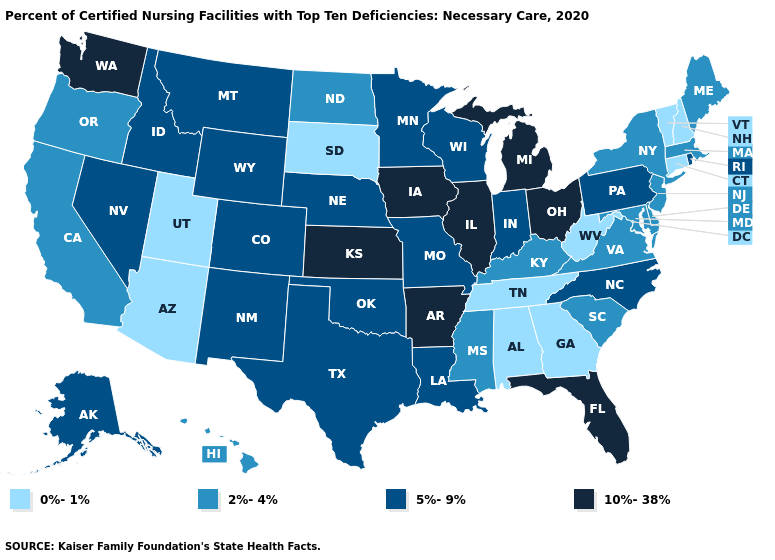Among the states that border Michigan , does Wisconsin have the lowest value?
Write a very short answer. Yes. Name the states that have a value in the range 5%-9%?
Write a very short answer. Alaska, Colorado, Idaho, Indiana, Louisiana, Minnesota, Missouri, Montana, Nebraska, Nevada, New Mexico, North Carolina, Oklahoma, Pennsylvania, Rhode Island, Texas, Wisconsin, Wyoming. What is the value of Arizona?
Write a very short answer. 0%-1%. Name the states that have a value in the range 5%-9%?
Be succinct. Alaska, Colorado, Idaho, Indiana, Louisiana, Minnesota, Missouri, Montana, Nebraska, Nevada, New Mexico, North Carolina, Oklahoma, Pennsylvania, Rhode Island, Texas, Wisconsin, Wyoming. What is the lowest value in states that border Louisiana?
Quick response, please. 2%-4%. What is the highest value in the MidWest ?
Quick response, please. 10%-38%. Does Virginia have the highest value in the USA?
Short answer required. No. What is the highest value in states that border Missouri?
Write a very short answer. 10%-38%. What is the value of Montana?
Answer briefly. 5%-9%. Name the states that have a value in the range 5%-9%?
Quick response, please. Alaska, Colorado, Idaho, Indiana, Louisiana, Minnesota, Missouri, Montana, Nebraska, Nevada, New Mexico, North Carolina, Oklahoma, Pennsylvania, Rhode Island, Texas, Wisconsin, Wyoming. What is the lowest value in the MidWest?
Answer briefly. 0%-1%. What is the lowest value in states that border Washington?
Answer briefly. 2%-4%. Does Georgia have a lower value than Florida?
Be succinct. Yes. Name the states that have a value in the range 2%-4%?
Short answer required. California, Delaware, Hawaii, Kentucky, Maine, Maryland, Massachusetts, Mississippi, New Jersey, New York, North Dakota, Oregon, South Carolina, Virginia. Among the states that border West Virginia , which have the lowest value?
Concise answer only. Kentucky, Maryland, Virginia. 